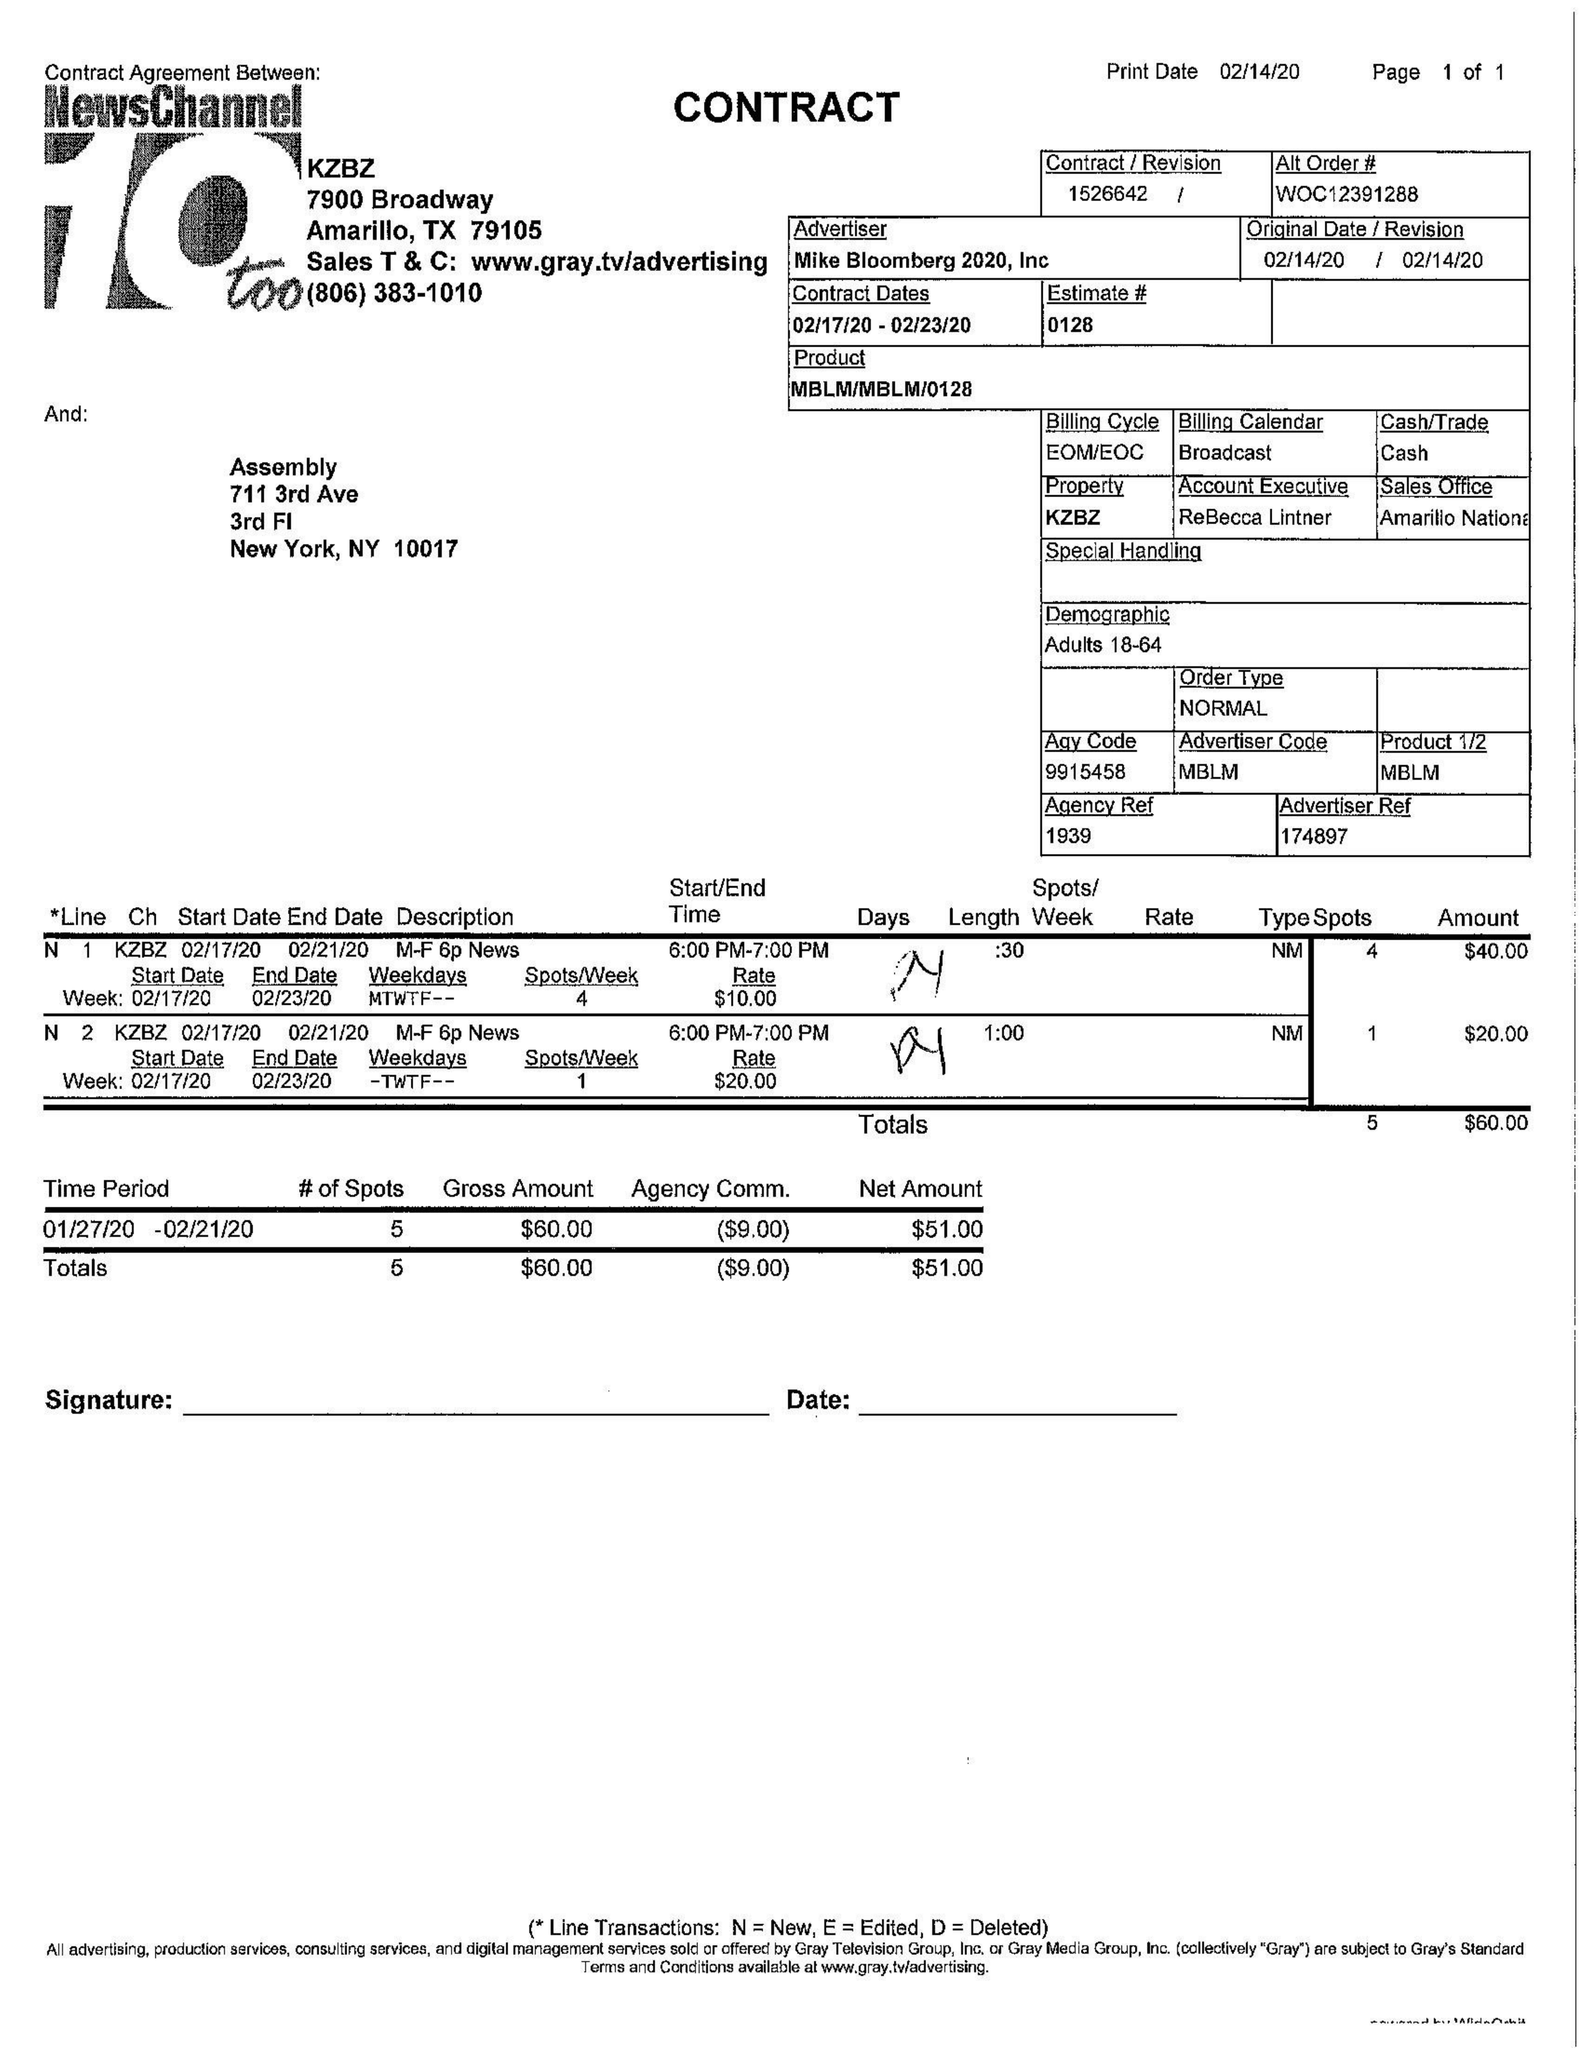What is the value for the advertiser?
Answer the question using a single word or phrase. MIKE BLOOMBERG 2020, INC 